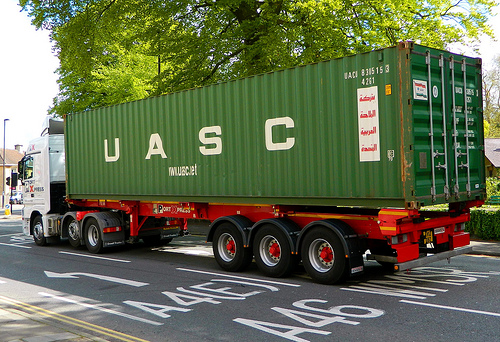Imagining the scene in a different era, what would it look like? In a different era, such as the early 1900s, the scene might replace the modern truck with a horse-drawn carriage, cobblestone streets instead of paved roads, and more classical architectural styles for nearby buildings. What if this image was from the far future? In the far future, the truck might be a self-driving electric vehicle with solar panels on the container. The surroundings could include automated drones for package delivery, advanced urban infrastructure, and smart road markings with embedded LEDs for dynamic traffic management. 